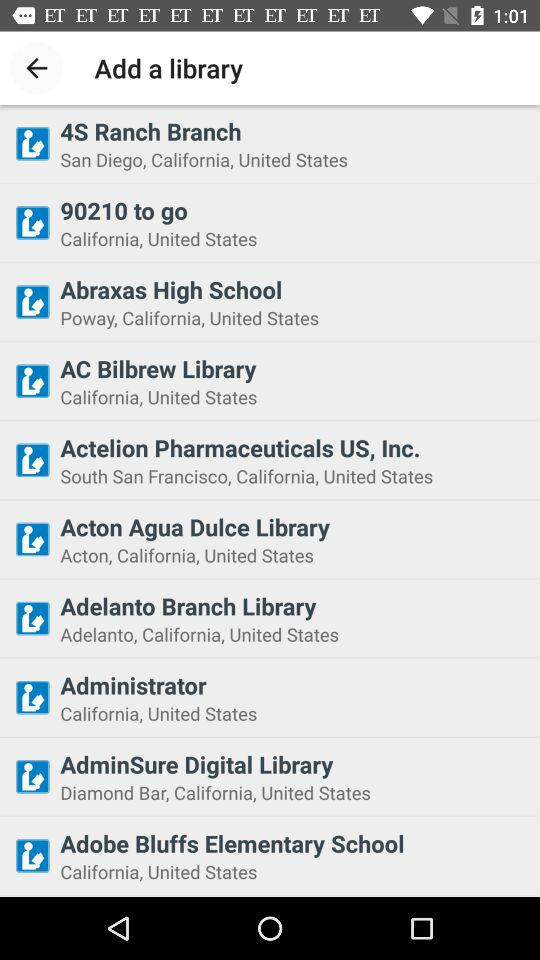How many libraries are in California?
Answer the question using a single word or phrase. 10 